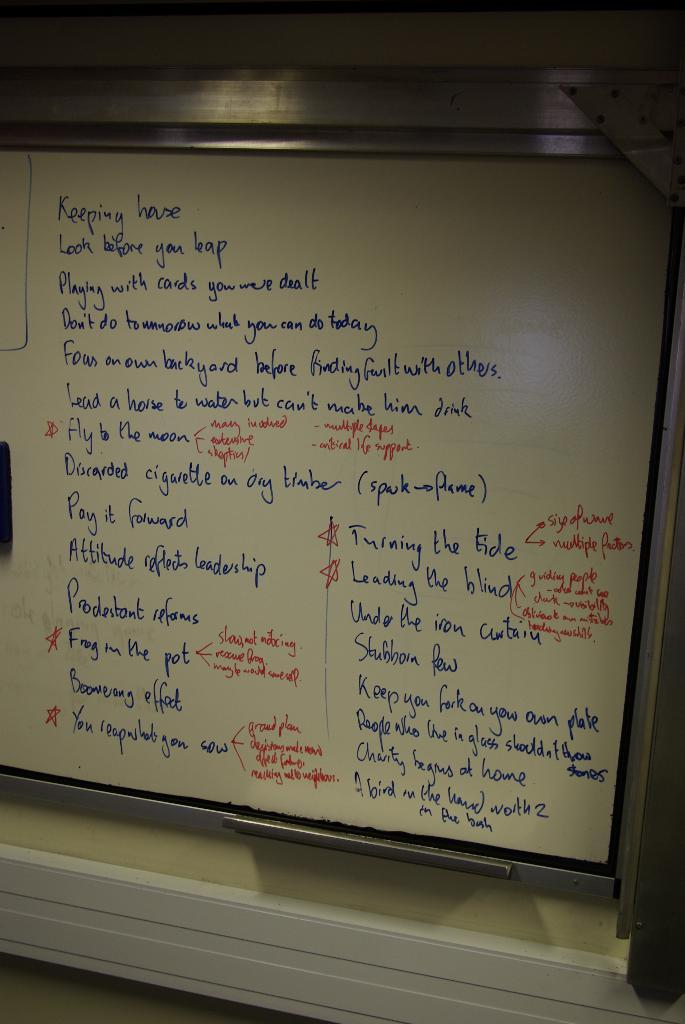<image>
Summarize the visual content of the image. A whiteboard has a list of sayings, including ‘look before you leap’ and ‘pay it forward’, on it. 